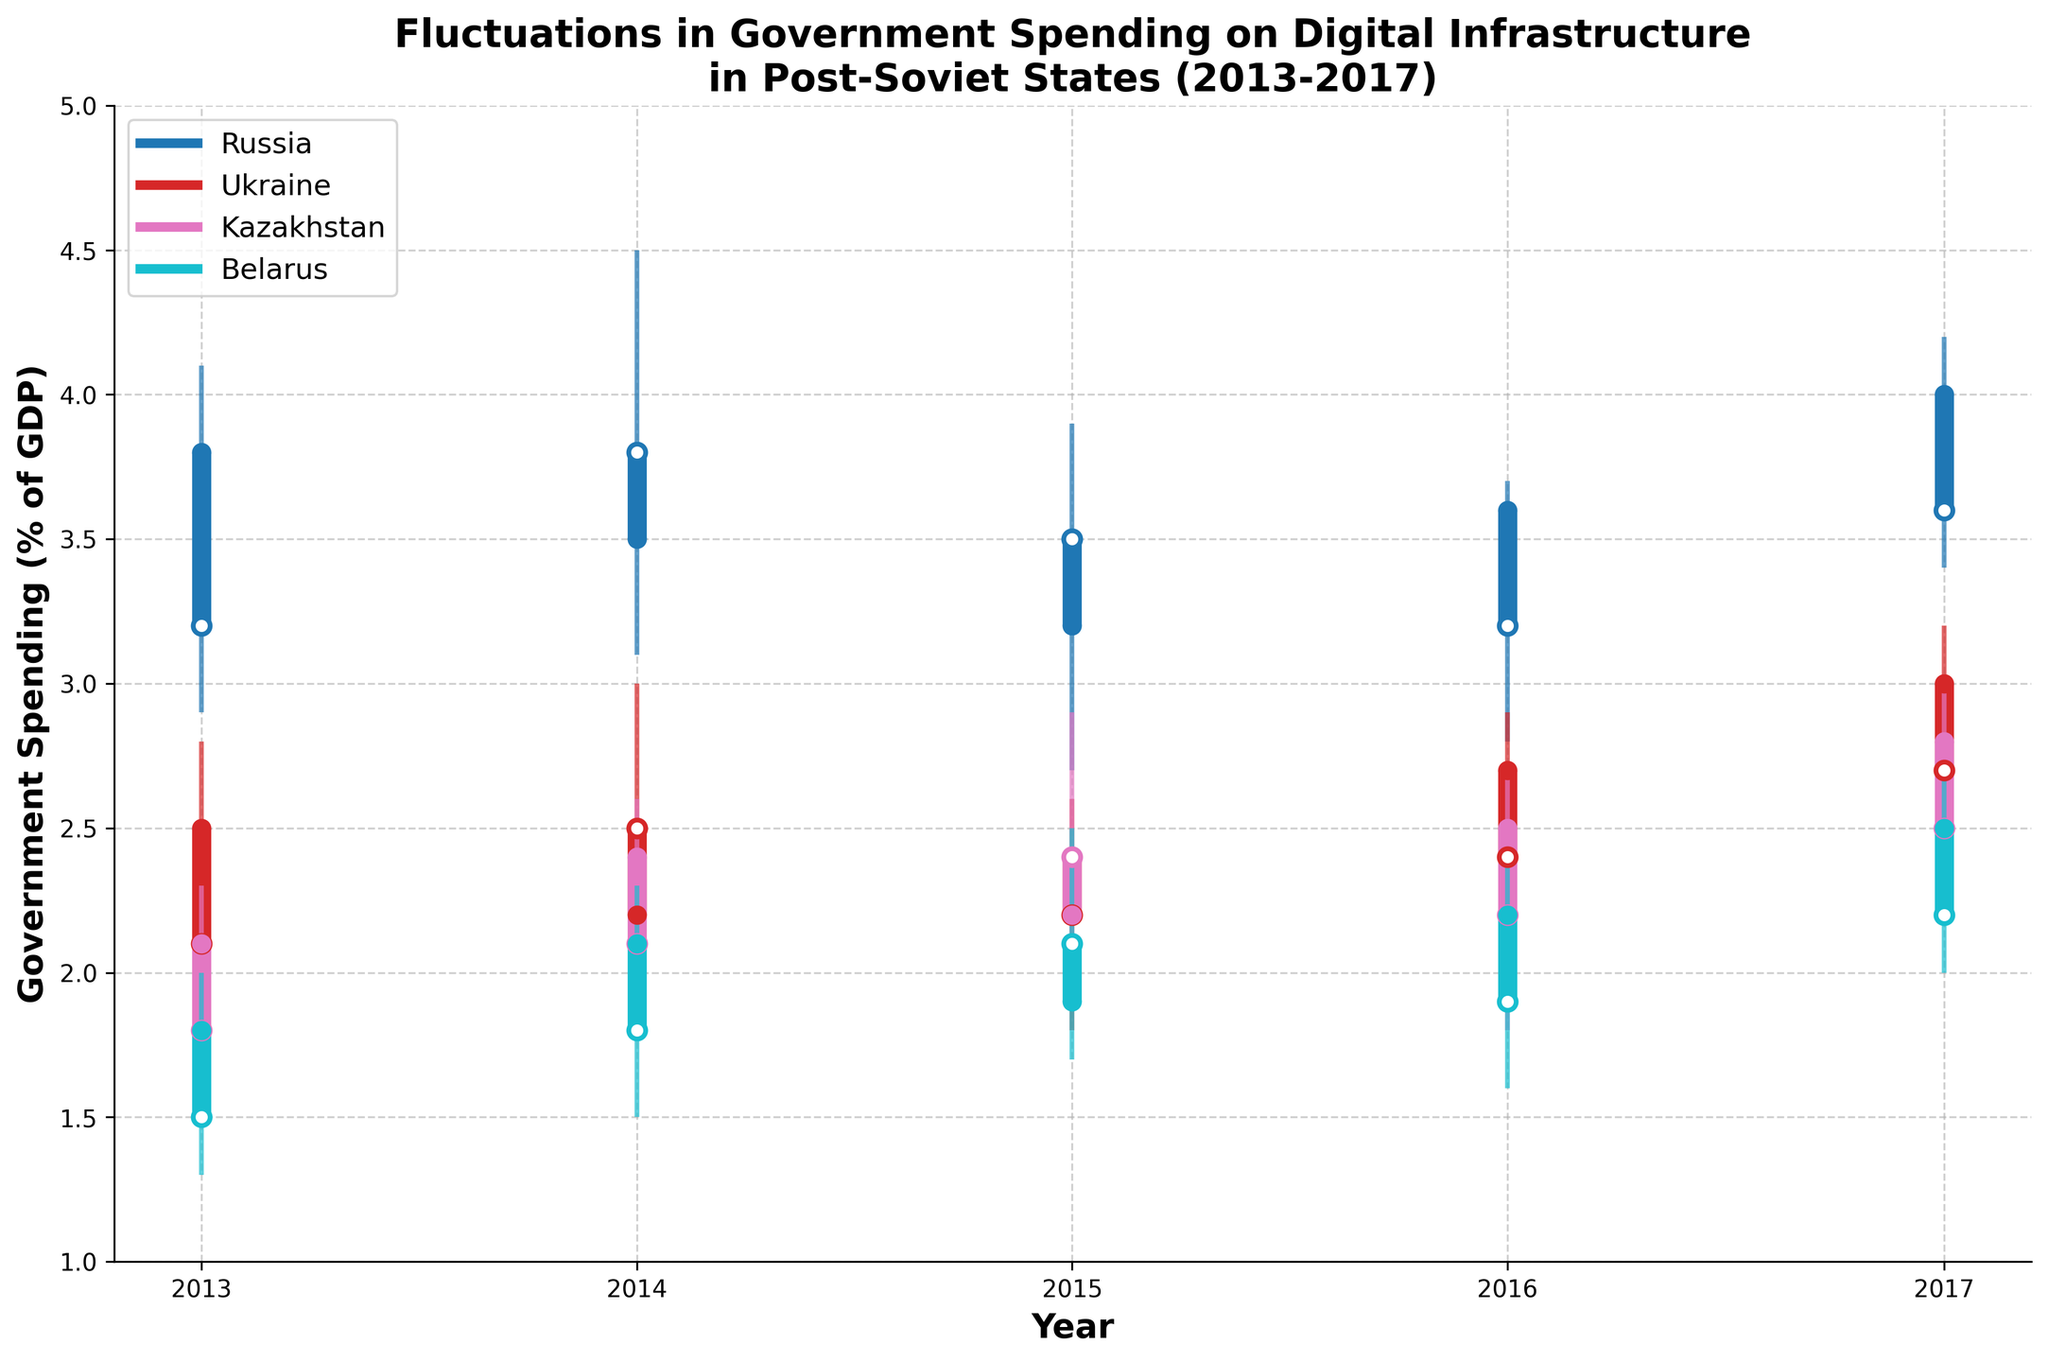What is the highest government spending on digital infrastructure in Russia from 2013 to 2017? The highest spending can be identified from the 'High' values for each year in Russia. From the chart, the highest 'High' value for Russia is in 2014, with a value of 4.5% of GDP.
Answer: 4.5% What is the average closing government spending on digital infrastructure in Belarus between 2013 and 2017? The 'Close' values for Belarus over the given period are 1.8%, 2.1%, 1.9%, 2.2%, and 2.5%. Averaging these values gives (1.8 + 2.1 + 1.9 + 2.2 + 2.5)/5 = 10.5/5 = 2.1%.
Answer: 2.1% Which country had the lowest annual government spending on digital infrastructure in 2015? The lowest spending can be found by identifying the lowest 'Low' value in 2015 for each country. From the chart, in 2015, Russia had 2.7%, Ukraine had 1.8%, Kazakhstan had 2.0%, and Belarus had 1.7%. Therefore, Belarus had the lowest spending of 1.7%.
Answer: Belarus How does the range of government spending from 'Low' to 'High' in Ukraine in 2014 compare to that in Kazakhstan in 2016? For Ukraine in 2014, the range is calculated as 3.0 (High) - 2.0 (Low) = 1.0 percentage points. For Kazakhstan in 2016, the range is 2.7 (High) - 1.8 (Low) = 0.9 percentage points. Thus, Ukraine in 2014 had a 0.1 percentage points higher range than Kazakhstan in 2016.
Answer: Ukraine's range is higher by 0.1 percentage points Which country exhibited the most consistent government spending on digital infrastructure between 2013 and 2017? Consistency can be evaluated based on the smallest variance or range in 'Low' to 'High' spending values. By observing the chart, Kazakhstan shows the least variability, as its 'High' and 'Low' values are closer together compared to other countries.
Answer: Kazakhstan In which year did Russia witness the largest drop in closing government spending on digital infrastructure compared to the previous year, and what was the drop? Comparing the 'Close' values year by year for Russia: from 2013 to 2014, the drop was 3.8% - 3.5% = 0.3%; from 2014 to 2015, 3.5% - 3.2% = 0.3%; from 2015 to 2016, 3.2% - 3.6% = -0.4%; and from 2016 to 2017, 3.6% - 4.0% = -0.4%. The largest drop was in 2014 to 2015, with a decrease of 0.3%.
Answer: 2014-2015, 0.3% What trend can be observed about Ukraine's spending on digital infrastructure from 2013 to 2017? Observing the 'Close' values for Ukraine shows an overall increasing trend: 2.5% (2013), 2.2% (2014), 2.4% (2015), 2.7% (2016), and 3.0% (2017). Thus, Ukraine's spending generally increased over the years.
Answer: Increasing trend 